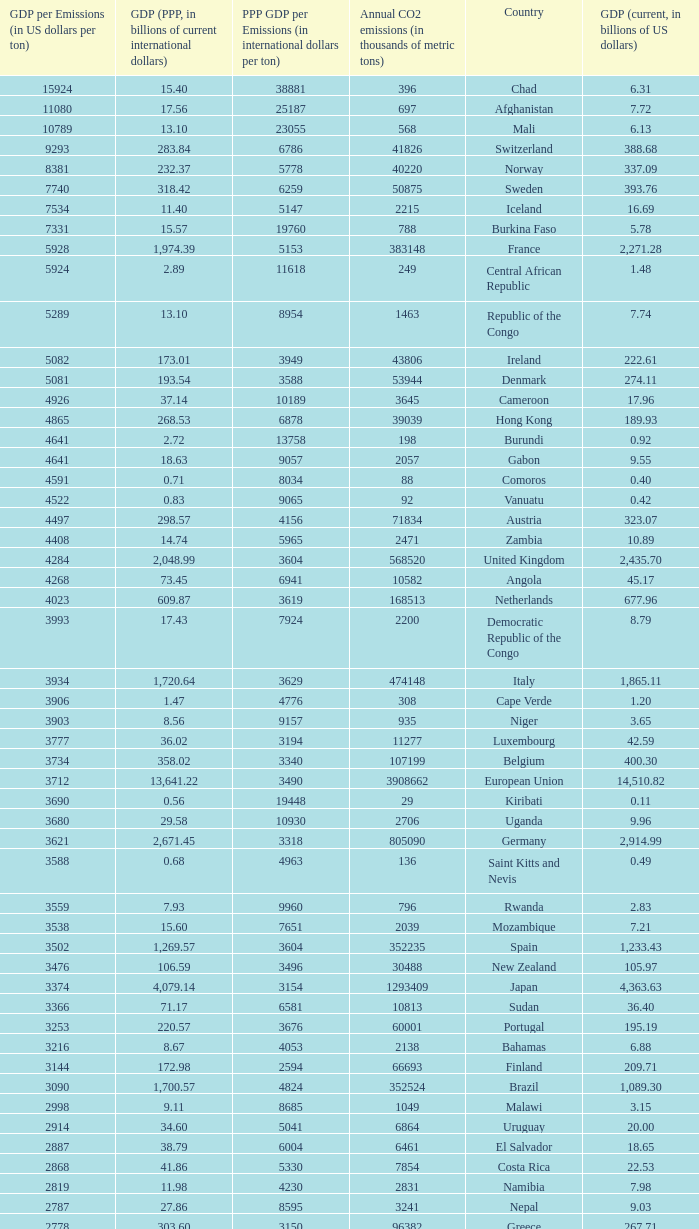When the gdp (ppp, in billions of current international dollars) is 7.93, what is the maximum ppp gdp per emissions (in international dollars per ton)? 9960.0. 